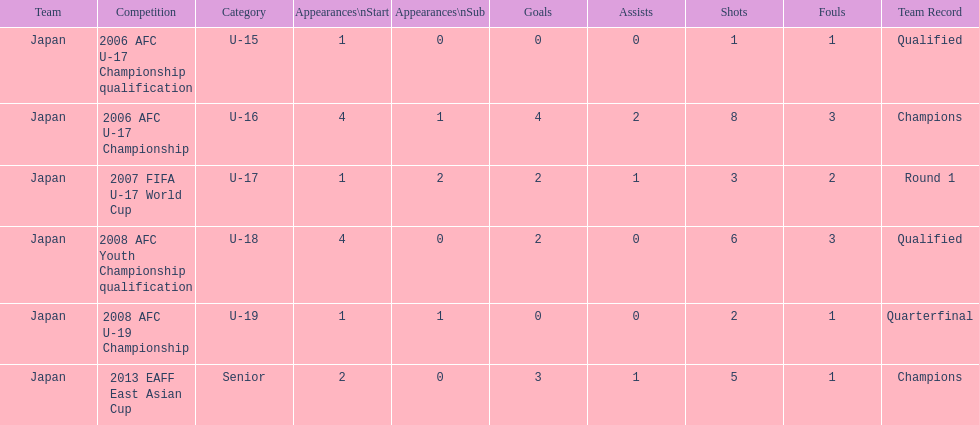How many total goals were scored? 11. Could you parse the entire table? {'header': ['Team', 'Competition', 'Category', 'Appearances\\nStart', 'Appearances\\nSub', 'Goals', 'Assists', 'Shots', 'Fouls', 'Team Record'], 'rows': [['Japan', '2006 AFC U-17 Championship qualification', 'U-15', '1', '0', '0', '0', '1', '1', 'Qualified'], ['Japan', '2006 AFC U-17 Championship', 'U-16', '4', '1', '4', '2', '8', '3', 'Champions'], ['Japan', '2007 FIFA U-17 World Cup', 'U-17', '1', '2', '2', '1', '3', '2', 'Round 1'], ['Japan', '2008 AFC Youth Championship qualification', 'U-18', '4', '0', '2', '0', '6', '3', 'Qualified'], ['Japan', '2008 AFC U-19 Championship', 'U-19', '1', '1', '0', '0', '2', '1', 'Quarterfinal'], ['Japan', '2013 EAFF East Asian Cup', 'Senior', '2', '0', '3', '1', '5', '1', 'Champions']]} 